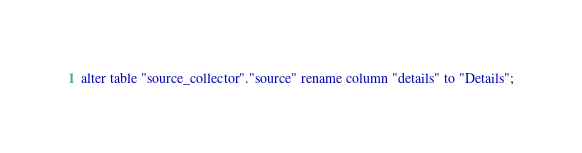<code> <loc_0><loc_0><loc_500><loc_500><_SQL_>alter table "source_collector"."source" rename column "details" to "Details";
</code> 